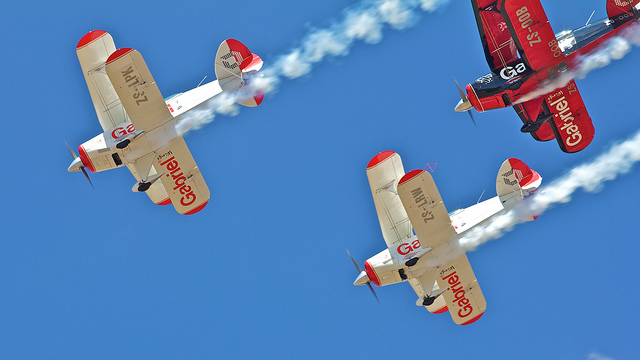How many planes can be seen? There are three planes in formation against the blue sky, each emitting a trail of smoke to accentuate their flight path. 